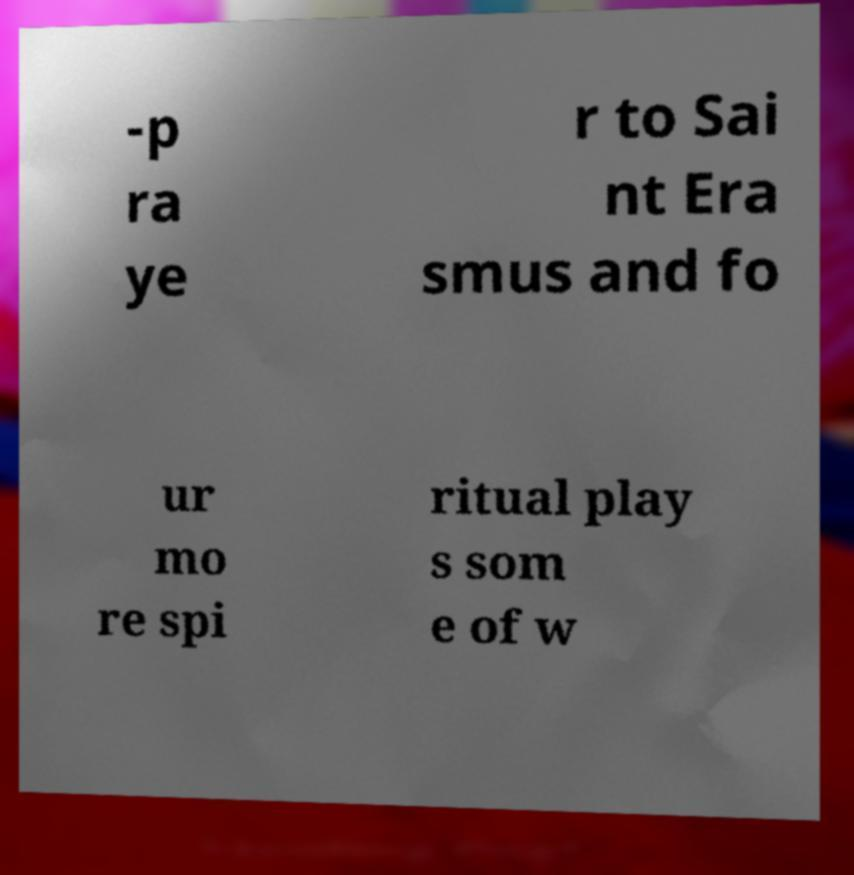What messages or text are displayed in this image? I need them in a readable, typed format. -p ra ye r to Sai nt Era smus and fo ur mo re spi ritual play s som e of w 